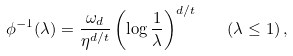<formula> <loc_0><loc_0><loc_500><loc_500>\phi ^ { - 1 } ( \lambda ) = \frac { \omega _ { d } } { \eta ^ { d / t } } \left ( \log \frac { 1 } { \lambda } \right ) ^ { d / t } \quad ( \lambda \leq 1 ) \, ,</formula> 